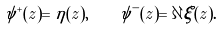Convert formula to latex. <formula><loc_0><loc_0><loc_500><loc_500>\psi ^ { + } ( z ) = \eta ( z ) , \quad \psi ^ { - } ( z ) = \partial \xi ( z ) .</formula> 